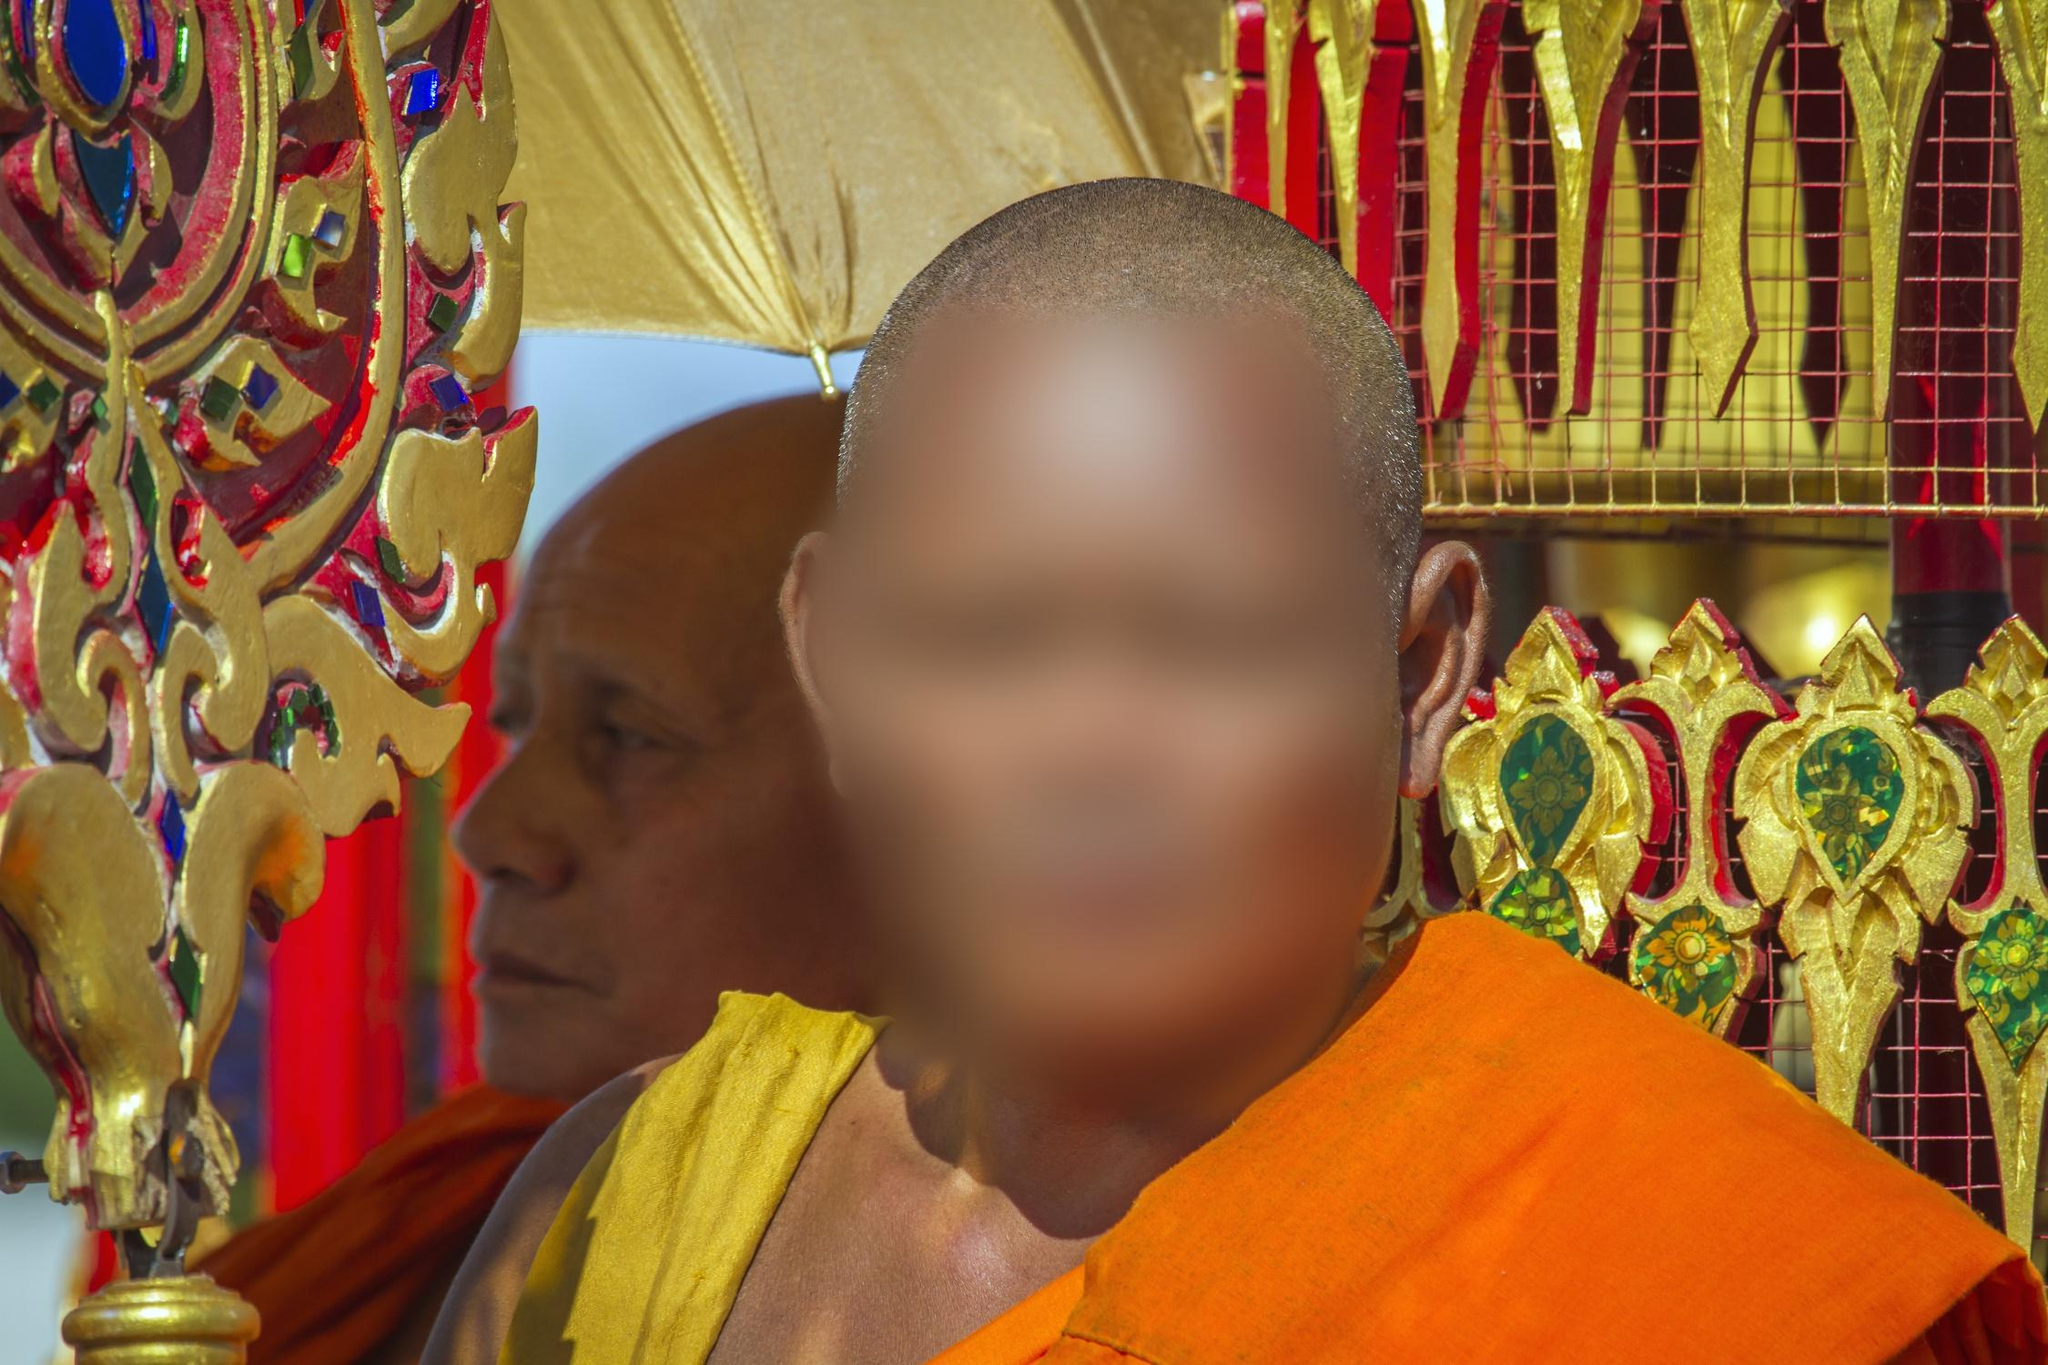How do the colors in the monk's robes play a role in Buddhist traditions? In Buddhist tradition, the color of a monk's robe often holds deep symbolic meaning. Orange, as seen in the image, is one of the most common colors. It symbolizes simplicity and detachment from materialism. Originally, the dye for these robes comes from natural sources like tree bark, spices, and flowers, which is why traditional robes have a color that connects them to the earth and nature. What do the other colors in the image signify? The other colors in the image, particularly the gold and reds adorning the temple, represent other aspects of Buddhism. Gold symbolizes the sun or enlightenment—spiritual wealth rather than material wealth. Red often stands for life force, preservation, and sacredness. These colors combined create a visually rich environment that supports the spiritual atmosphere of the temple. 